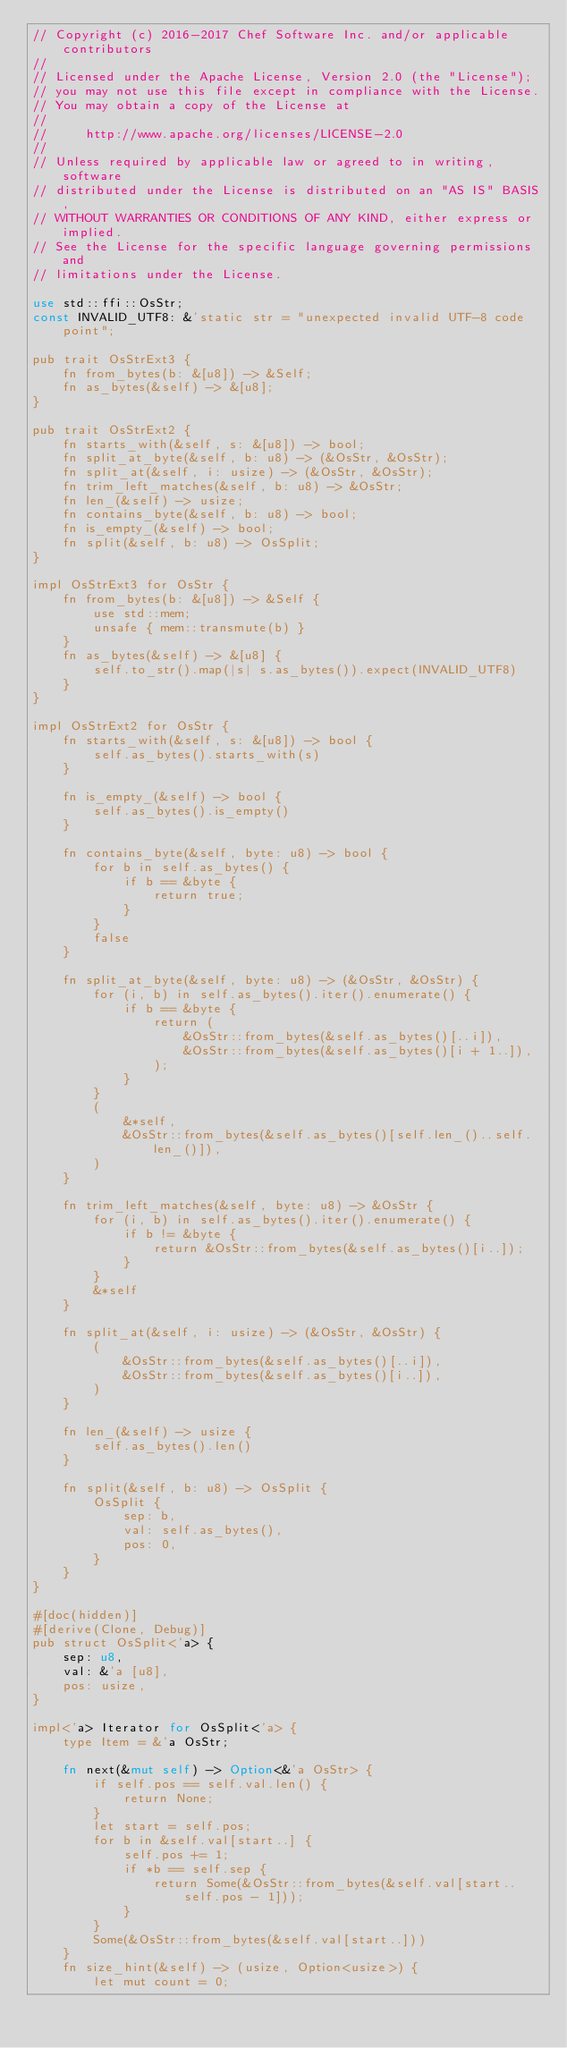<code> <loc_0><loc_0><loc_500><loc_500><_Rust_>// Copyright (c) 2016-2017 Chef Software Inc. and/or applicable contributors
//
// Licensed under the Apache License, Version 2.0 (the "License");
// you may not use this file except in compliance with the License.
// You may obtain a copy of the License at
//
//     http://www.apache.org/licenses/LICENSE-2.0
//
// Unless required by applicable law or agreed to in writing, software
// distributed under the License is distributed on an "AS IS" BASIS,
// WITHOUT WARRANTIES OR CONDITIONS OF ANY KIND, either express or implied.
// See the License for the specific language governing permissions and
// limitations under the License.

use std::ffi::OsStr;
const INVALID_UTF8: &'static str = "unexpected invalid UTF-8 code point";

pub trait OsStrExt3 {
    fn from_bytes(b: &[u8]) -> &Self;
    fn as_bytes(&self) -> &[u8];
}

pub trait OsStrExt2 {
    fn starts_with(&self, s: &[u8]) -> bool;
    fn split_at_byte(&self, b: u8) -> (&OsStr, &OsStr);
    fn split_at(&self, i: usize) -> (&OsStr, &OsStr);
    fn trim_left_matches(&self, b: u8) -> &OsStr;
    fn len_(&self) -> usize;
    fn contains_byte(&self, b: u8) -> bool;
    fn is_empty_(&self) -> bool;
    fn split(&self, b: u8) -> OsSplit;
}

impl OsStrExt3 for OsStr {
    fn from_bytes(b: &[u8]) -> &Self {
        use std::mem;
        unsafe { mem::transmute(b) }
    }
    fn as_bytes(&self) -> &[u8] {
        self.to_str().map(|s| s.as_bytes()).expect(INVALID_UTF8)
    }
}

impl OsStrExt2 for OsStr {
    fn starts_with(&self, s: &[u8]) -> bool {
        self.as_bytes().starts_with(s)
    }

    fn is_empty_(&self) -> bool {
        self.as_bytes().is_empty()
    }

    fn contains_byte(&self, byte: u8) -> bool {
        for b in self.as_bytes() {
            if b == &byte {
                return true;
            }
        }
        false
    }

    fn split_at_byte(&self, byte: u8) -> (&OsStr, &OsStr) {
        for (i, b) in self.as_bytes().iter().enumerate() {
            if b == &byte {
                return (
                    &OsStr::from_bytes(&self.as_bytes()[..i]),
                    &OsStr::from_bytes(&self.as_bytes()[i + 1..]),
                );
            }
        }
        (
            &*self,
            &OsStr::from_bytes(&self.as_bytes()[self.len_()..self.len_()]),
        )
    }

    fn trim_left_matches(&self, byte: u8) -> &OsStr {
        for (i, b) in self.as_bytes().iter().enumerate() {
            if b != &byte {
                return &OsStr::from_bytes(&self.as_bytes()[i..]);
            }
        }
        &*self
    }

    fn split_at(&self, i: usize) -> (&OsStr, &OsStr) {
        (
            &OsStr::from_bytes(&self.as_bytes()[..i]),
            &OsStr::from_bytes(&self.as_bytes()[i..]),
        )
    }

    fn len_(&self) -> usize {
        self.as_bytes().len()
    }

    fn split(&self, b: u8) -> OsSplit {
        OsSplit {
            sep: b,
            val: self.as_bytes(),
            pos: 0,
        }
    }
}

#[doc(hidden)]
#[derive(Clone, Debug)]
pub struct OsSplit<'a> {
    sep: u8,
    val: &'a [u8],
    pos: usize,
}

impl<'a> Iterator for OsSplit<'a> {
    type Item = &'a OsStr;

    fn next(&mut self) -> Option<&'a OsStr> {
        if self.pos == self.val.len() {
            return None;
        }
        let start = self.pos;
        for b in &self.val[start..] {
            self.pos += 1;
            if *b == self.sep {
                return Some(&OsStr::from_bytes(&self.val[start..self.pos - 1]));
            }
        }
        Some(&OsStr::from_bytes(&self.val[start..]))
    }
    fn size_hint(&self) -> (usize, Option<usize>) {
        let mut count = 0;</code> 